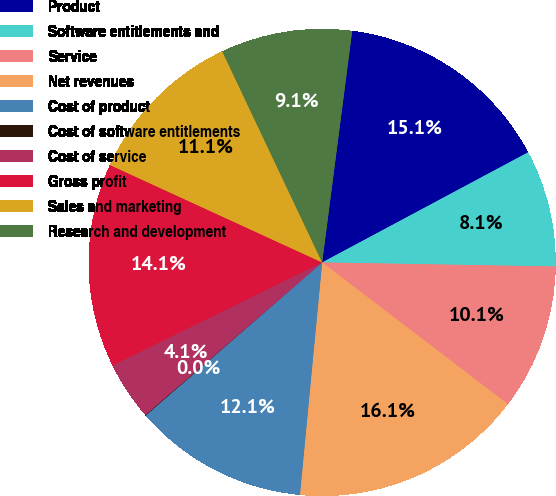Convert chart to OTSL. <chart><loc_0><loc_0><loc_500><loc_500><pie_chart><fcel>Product<fcel>Software entitlements and<fcel>Service<fcel>Net revenues<fcel>Cost of product<fcel>Cost of software entitlements<fcel>Cost of service<fcel>Gross profit<fcel>Sales and marketing<fcel>Research and development<nl><fcel>15.13%<fcel>8.09%<fcel>10.1%<fcel>16.14%<fcel>12.11%<fcel>0.04%<fcel>4.06%<fcel>14.12%<fcel>11.11%<fcel>9.09%<nl></chart> 